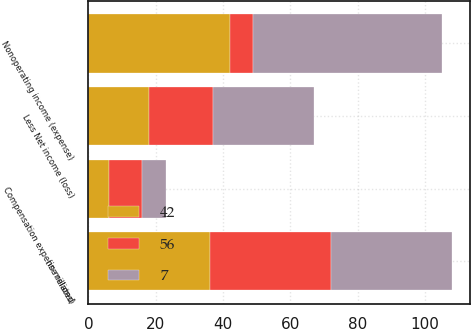Convert chart. <chart><loc_0><loc_0><loc_500><loc_500><stacked_bar_chart><ecel><fcel>(in millions)<fcel>Nonoperating income (expense)<fcel>Less Net income (loss)<fcel>Compensation expense related<nl><fcel>7<fcel>36<fcel>56<fcel>30<fcel>7<nl><fcel>56<fcel>36<fcel>7<fcel>19<fcel>10<nl><fcel>42<fcel>36<fcel>42<fcel>18<fcel>6<nl></chart> 